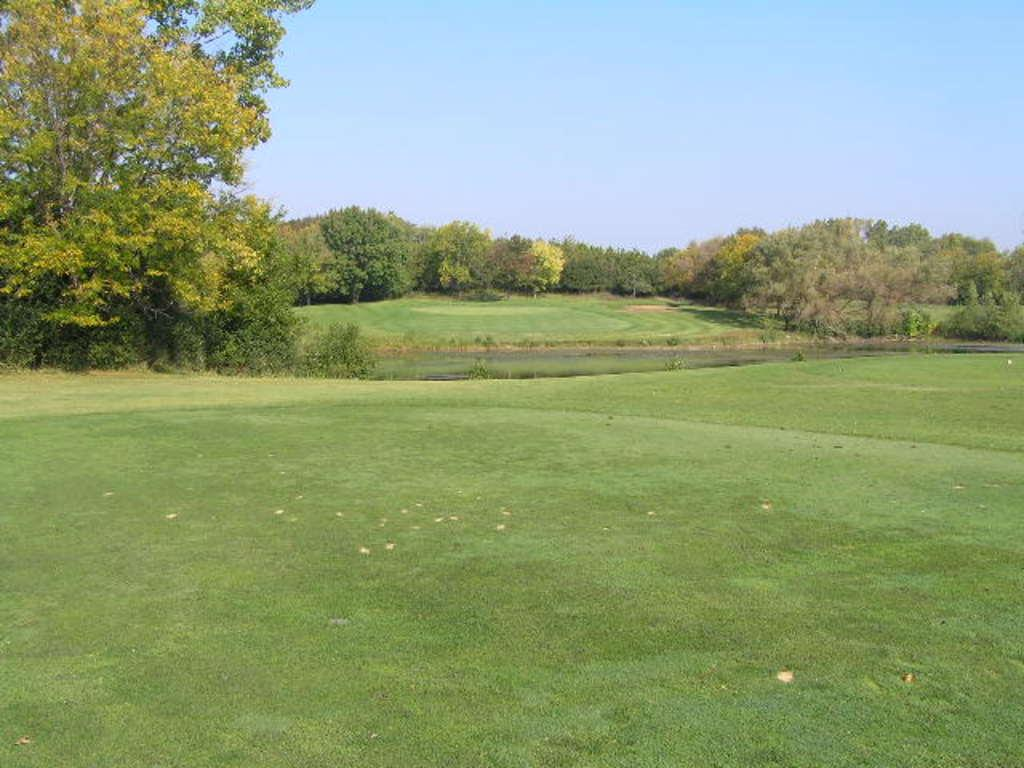What type of vegetation is visible in the image? There is grass and trees in the image. Can you describe the natural environment depicted in the image? The image features a grassy area with trees. What type of crown is the pet wearing in the image? There is no pet or crown present in the image; it only features grass and trees. 